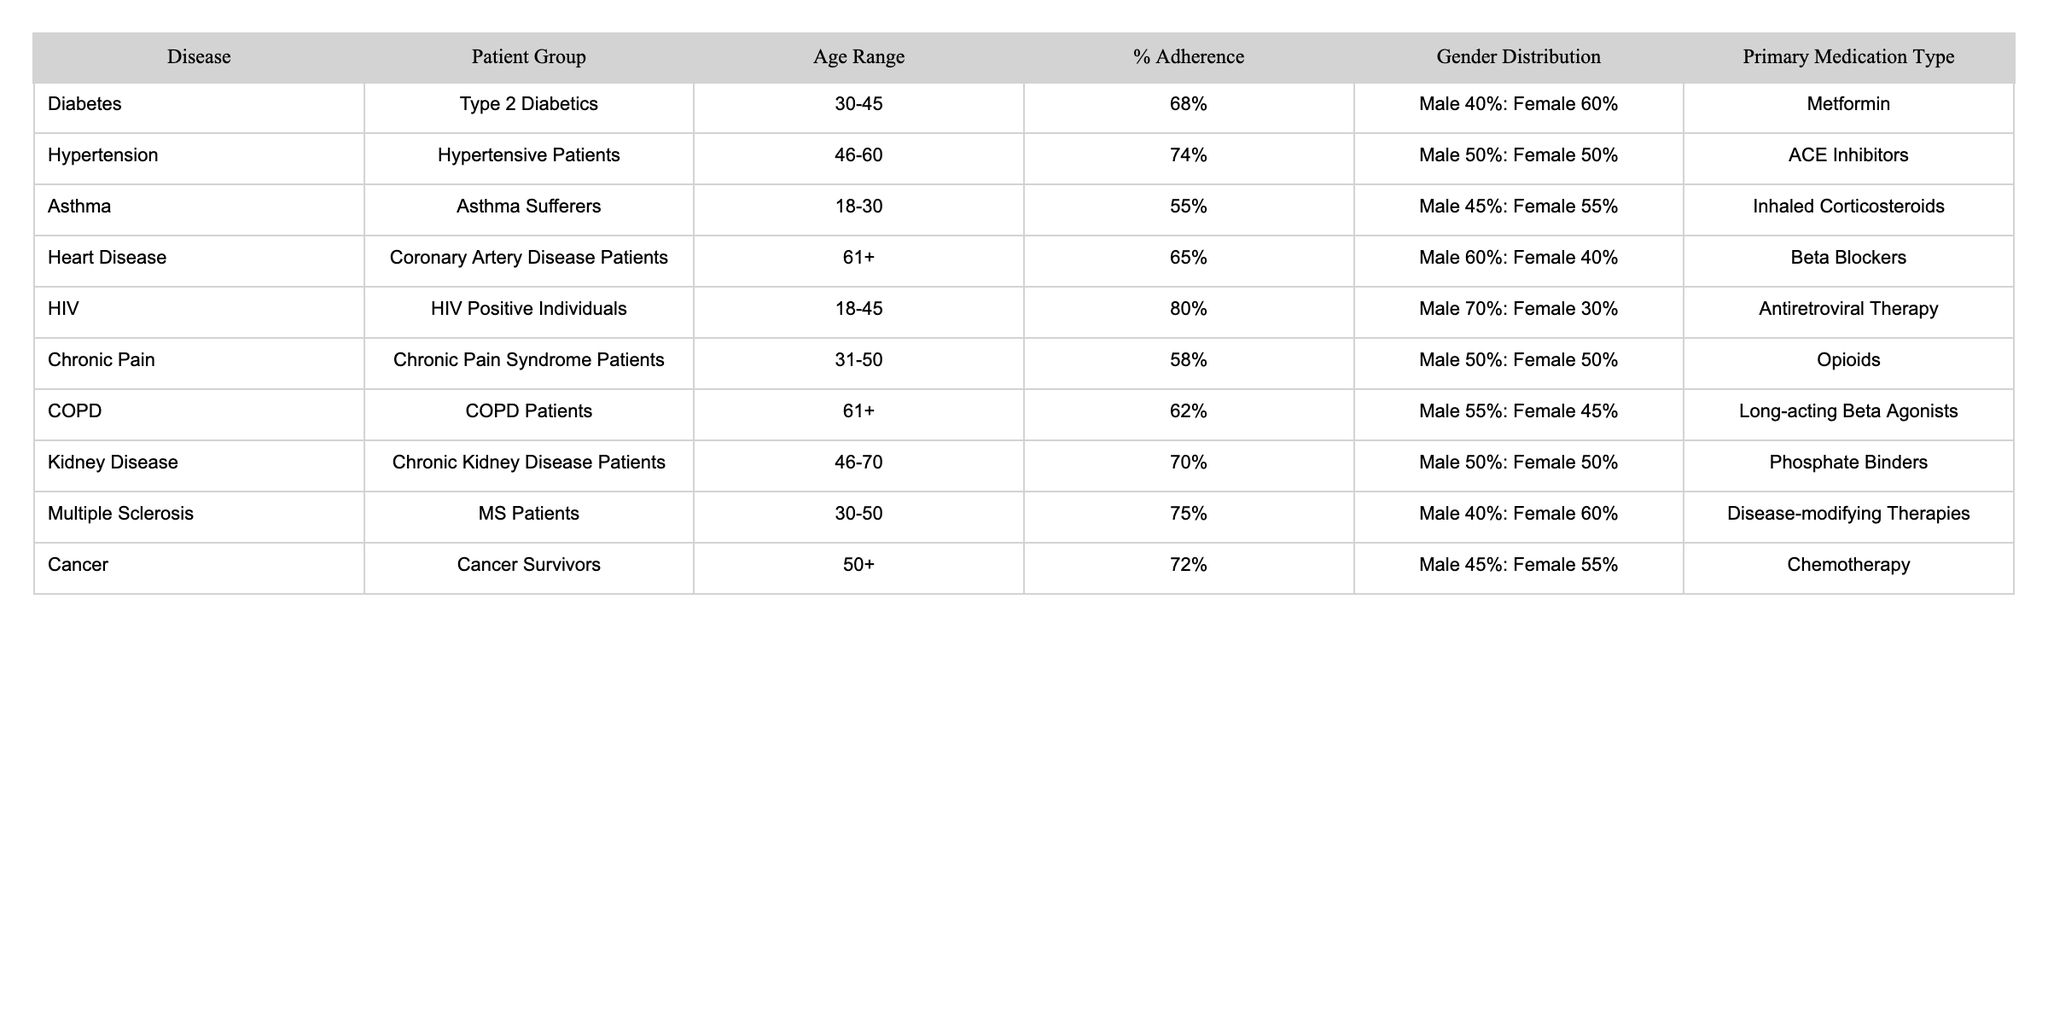What is the adherence rate for HIV positive individuals? The table shows that the % Adherence for HIV positive individuals is listed as 80%.
Answer: 80% Which disease has the highest medication adherence rate? By comparing the % Adherence values, HIV with 80% has the highest adherence rate among the diseases listed.
Answer: HIV What percentage of Chronic Pain Syndrome Patients adhere to their medication? The table indicates that the % Adherence for Chronic Pain Syndrome Patients is 58%.
Answer: 58% Is the gender distribution for hypertension patients equal? The gender distribution for hypertensive patients is Male 50% and Female 50%, indicating equality in distribution.
Answer: Yes What is the average adherence rate for the diseases where patients are aged 61 and older? The % Adherence for patients aged 61 and older is 65% (Heart Disease) and 62% (COPD), so the average is (65 + 62) / 2 = 63.5%.
Answer: 63.5% Which medication type is the most common among the patient groups listed? Reviewing the table, the most common medication type is different for each group; thus, no single type dominates among them.
Answer: None What is the difference in adherence rates between Asthma sufferers and Heart Disease patients? The % Adherence for Asthma patients is 55% and for Heart Disease patients is 65%, resulting in a difference of 65% - 55% = 10%.
Answer: 10% Do Male patients have a higher adherence rate in diabetes compared to female patients? Male diabetes patients have an adherence rate of 68%, while female patients are not explicitly mentioned. Since the overall adherence is 68%, we cannot say definitively for females, but the adherence is primarily driven by male rates.
Answer: Cannot determine What percentage of patients in the 30-45 age range adhere to their medications across diseases? In the 30-45 age range, the only available value is from the Diabetes group, which is 68%. Since there are no other age ranges listed, the answer relies solely on diabetes findings.
Answer: 68% What is the % Adherence for Multiple Sclerosis Patients, and how does that compare to Chronic Kidney Disease Patients? The % Adherence for Multiple Sclerosis patients is 75% and for Chronic Kidney Disease patients is 70%, indicating Multiple Sclerosis patients have a higher adherence by 5%.
Answer: 5% higher 